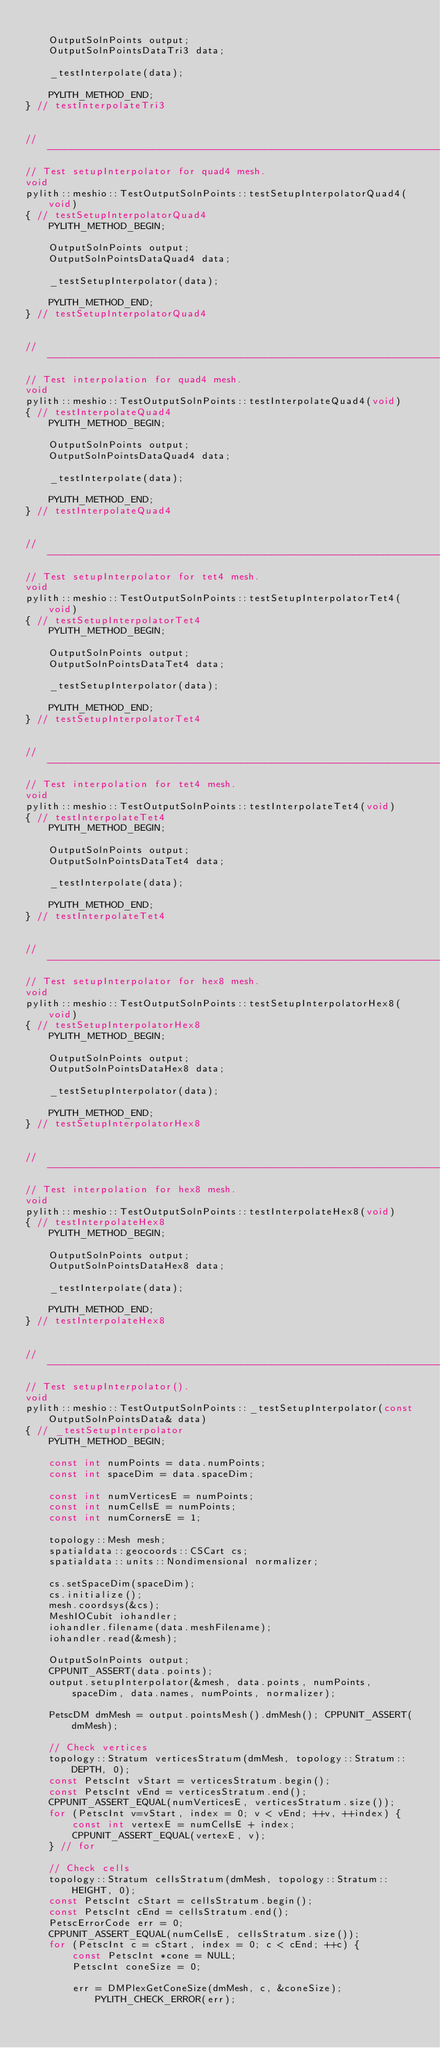<code> <loc_0><loc_0><loc_500><loc_500><_C++_>
    OutputSolnPoints output;
    OutputSolnPointsDataTri3 data;

    _testInterpolate(data);

    PYLITH_METHOD_END;
} // testInterpolateTri3


// ----------------------------------------------------------------------
// Test setupInterpolator for quad4 mesh.
void
pylith::meshio::TestOutputSolnPoints::testSetupInterpolatorQuad4(void)
{ // testSetupInterpolatorQuad4
    PYLITH_METHOD_BEGIN;

    OutputSolnPoints output;
    OutputSolnPointsDataQuad4 data;

    _testSetupInterpolator(data);

    PYLITH_METHOD_END;
} // testSetupInterpolatorQuad4


// ----------------------------------------------------------------------
// Test interpolation for quad4 mesh.
void
pylith::meshio::TestOutputSolnPoints::testInterpolateQuad4(void)
{ // testInterpolateQuad4
    PYLITH_METHOD_BEGIN;

    OutputSolnPoints output;
    OutputSolnPointsDataQuad4 data;

    _testInterpolate(data);

    PYLITH_METHOD_END;
} // testInterpolateQuad4


// ----------------------------------------------------------------------
// Test setupInterpolator for tet4 mesh.
void
pylith::meshio::TestOutputSolnPoints::testSetupInterpolatorTet4(void)
{ // testSetupInterpolatorTet4
    PYLITH_METHOD_BEGIN;

    OutputSolnPoints output;
    OutputSolnPointsDataTet4 data;

    _testSetupInterpolator(data);

    PYLITH_METHOD_END;
} // testSetupInterpolatorTet4


// ----------------------------------------------------------------------
// Test interpolation for tet4 mesh.
void
pylith::meshio::TestOutputSolnPoints::testInterpolateTet4(void)
{ // testInterpolateTet4
    PYLITH_METHOD_BEGIN;

    OutputSolnPoints output;
    OutputSolnPointsDataTet4 data;

    _testInterpolate(data);

    PYLITH_METHOD_END;
} // testInterpolateTet4


// ----------------------------------------------------------------------
// Test setupInterpolator for hex8 mesh.
void
pylith::meshio::TestOutputSolnPoints::testSetupInterpolatorHex8(void)
{ // testSetupInterpolatorHex8
    PYLITH_METHOD_BEGIN;

    OutputSolnPoints output;
    OutputSolnPointsDataHex8 data;

    _testSetupInterpolator(data);

    PYLITH_METHOD_END;
} // testSetupInterpolatorHex8


// ----------------------------------------------------------------------
// Test interpolation for hex8 mesh.
void
pylith::meshio::TestOutputSolnPoints::testInterpolateHex8(void)
{ // testInterpolateHex8
    PYLITH_METHOD_BEGIN;

    OutputSolnPoints output;
    OutputSolnPointsDataHex8 data;

    _testInterpolate(data);

    PYLITH_METHOD_END;
} // testInterpolateHex8


// ----------------------------------------------------------------------
// Test setupInterpolator().
void
pylith::meshio::TestOutputSolnPoints::_testSetupInterpolator(const OutputSolnPointsData& data)
{ // _testSetupInterpolator
    PYLITH_METHOD_BEGIN;

    const int numPoints = data.numPoints;
    const int spaceDim = data.spaceDim;

    const int numVerticesE = numPoints;
    const int numCellsE = numPoints;
    const int numCornersE = 1;

    topology::Mesh mesh;
    spatialdata::geocoords::CSCart cs;
    spatialdata::units::Nondimensional normalizer;

    cs.setSpaceDim(spaceDim);
    cs.initialize();
    mesh.coordsys(&cs);
    MeshIOCubit iohandler;
    iohandler.filename(data.meshFilename);
    iohandler.read(&mesh);

    OutputSolnPoints output;
    CPPUNIT_ASSERT(data.points);
    output.setupInterpolator(&mesh, data.points, numPoints, spaceDim, data.names, numPoints, normalizer);

    PetscDM dmMesh = output.pointsMesh().dmMesh(); CPPUNIT_ASSERT(dmMesh);

    // Check vertices
    topology::Stratum verticesStratum(dmMesh, topology::Stratum::DEPTH, 0);
    const PetscInt vStart = verticesStratum.begin();
    const PetscInt vEnd = verticesStratum.end();
    CPPUNIT_ASSERT_EQUAL(numVerticesE, verticesStratum.size());
    for (PetscInt v=vStart, index = 0; v < vEnd; ++v, ++index) {
        const int vertexE = numCellsE + index;
        CPPUNIT_ASSERT_EQUAL(vertexE, v);
    } // for

    // Check cells
    topology::Stratum cellsStratum(dmMesh, topology::Stratum::HEIGHT, 0);
    const PetscInt cStart = cellsStratum.begin();
    const PetscInt cEnd = cellsStratum.end();
    PetscErrorCode err = 0;
    CPPUNIT_ASSERT_EQUAL(numCellsE, cellsStratum.size());
    for (PetscInt c = cStart, index = 0; c < cEnd; ++c) {
        const PetscInt *cone = NULL;
        PetscInt coneSize = 0;

        err = DMPlexGetConeSize(dmMesh, c, &coneSize); PYLITH_CHECK_ERROR(err);</code> 